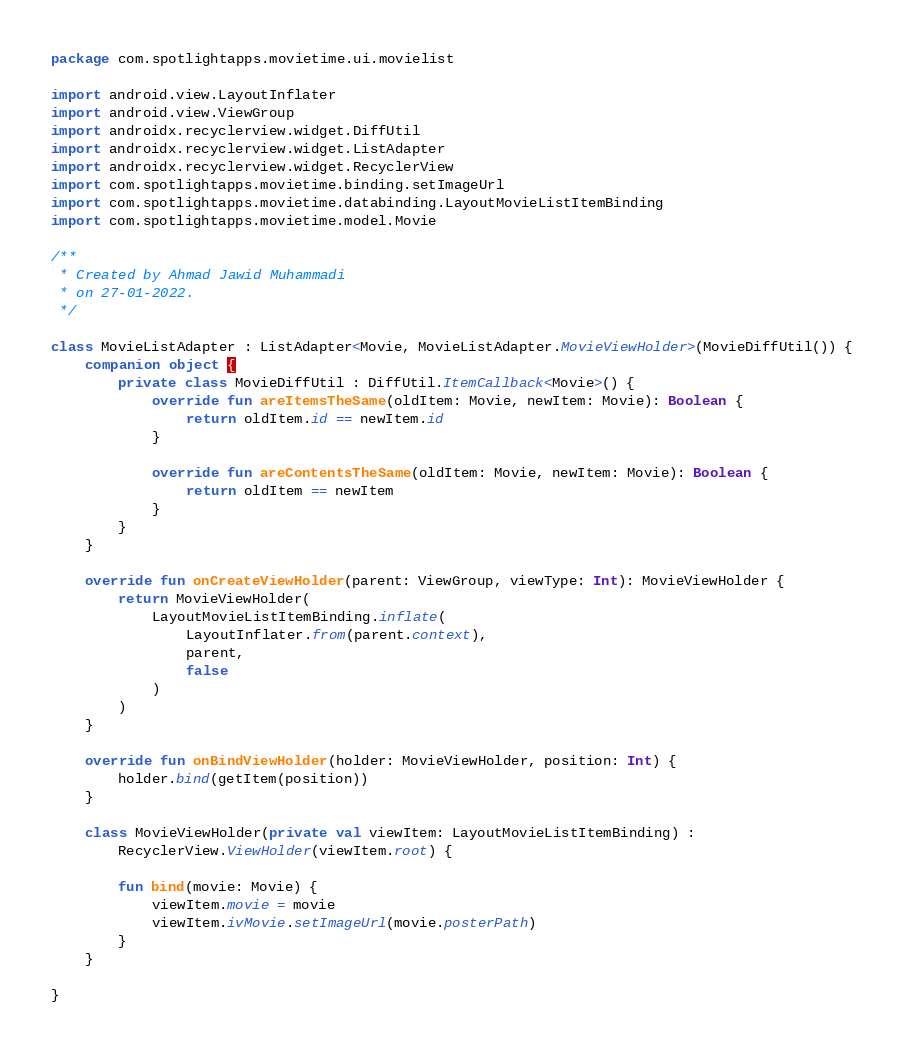Convert code to text. <code><loc_0><loc_0><loc_500><loc_500><_Kotlin_>package com.spotlightapps.movietime.ui.movielist

import android.view.LayoutInflater
import android.view.ViewGroup
import androidx.recyclerview.widget.DiffUtil
import androidx.recyclerview.widget.ListAdapter
import androidx.recyclerview.widget.RecyclerView
import com.spotlightapps.movietime.binding.setImageUrl
import com.spotlightapps.movietime.databinding.LayoutMovieListItemBinding
import com.spotlightapps.movietime.model.Movie

/**
 * Created by Ahmad Jawid Muhammadi
 * on 27-01-2022.
 */

class MovieListAdapter : ListAdapter<Movie, MovieListAdapter.MovieViewHolder>(MovieDiffUtil()) {
    companion object {
        private class MovieDiffUtil : DiffUtil.ItemCallback<Movie>() {
            override fun areItemsTheSame(oldItem: Movie, newItem: Movie): Boolean {
                return oldItem.id == newItem.id
            }

            override fun areContentsTheSame(oldItem: Movie, newItem: Movie): Boolean {
                return oldItem == newItem
            }
        }
    }

    override fun onCreateViewHolder(parent: ViewGroup, viewType: Int): MovieViewHolder {
        return MovieViewHolder(
            LayoutMovieListItemBinding.inflate(
                LayoutInflater.from(parent.context),
                parent,
                false
            )
        )
    }

    override fun onBindViewHolder(holder: MovieViewHolder, position: Int) {
        holder.bind(getItem(position))
    }

    class MovieViewHolder(private val viewItem: LayoutMovieListItemBinding) :
        RecyclerView.ViewHolder(viewItem.root) {

        fun bind(movie: Movie) {
            viewItem.movie = movie
            viewItem.ivMovie.setImageUrl(movie.posterPath)
        }
    }

}</code> 